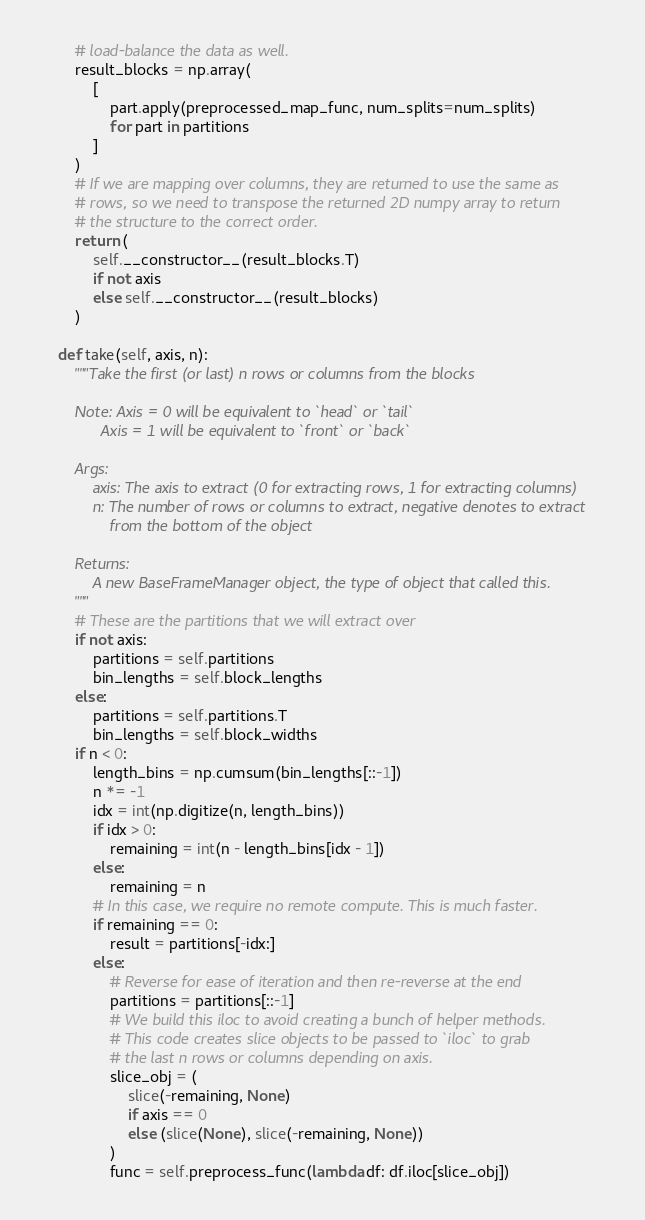Convert code to text. <code><loc_0><loc_0><loc_500><loc_500><_Python_>        # load-balance the data as well.
        result_blocks = np.array(
            [
                part.apply(preprocessed_map_func, num_splits=num_splits)
                for part in partitions
            ]
        )
        # If we are mapping over columns, they are returned to use the same as
        # rows, so we need to transpose the returned 2D numpy array to return
        # the structure to the correct order.
        return (
            self.__constructor__(result_blocks.T)
            if not axis
            else self.__constructor__(result_blocks)
        )

    def take(self, axis, n):
        """Take the first (or last) n rows or columns from the blocks

        Note: Axis = 0 will be equivalent to `head` or `tail`
              Axis = 1 will be equivalent to `front` or `back`

        Args:
            axis: The axis to extract (0 for extracting rows, 1 for extracting columns)
            n: The number of rows or columns to extract, negative denotes to extract
                from the bottom of the object

        Returns:
            A new BaseFrameManager object, the type of object that called this.
        """
        # These are the partitions that we will extract over
        if not axis:
            partitions = self.partitions
            bin_lengths = self.block_lengths
        else:
            partitions = self.partitions.T
            bin_lengths = self.block_widths
        if n < 0:
            length_bins = np.cumsum(bin_lengths[::-1])
            n *= -1
            idx = int(np.digitize(n, length_bins))
            if idx > 0:
                remaining = int(n - length_bins[idx - 1])
            else:
                remaining = n
            # In this case, we require no remote compute. This is much faster.
            if remaining == 0:
                result = partitions[-idx:]
            else:
                # Reverse for ease of iteration and then re-reverse at the end
                partitions = partitions[::-1]
                # We build this iloc to avoid creating a bunch of helper methods.
                # This code creates slice objects to be passed to `iloc` to grab
                # the last n rows or columns depending on axis.
                slice_obj = (
                    slice(-remaining, None)
                    if axis == 0
                    else (slice(None), slice(-remaining, None))
                )
                func = self.preprocess_func(lambda df: df.iloc[slice_obj])</code> 